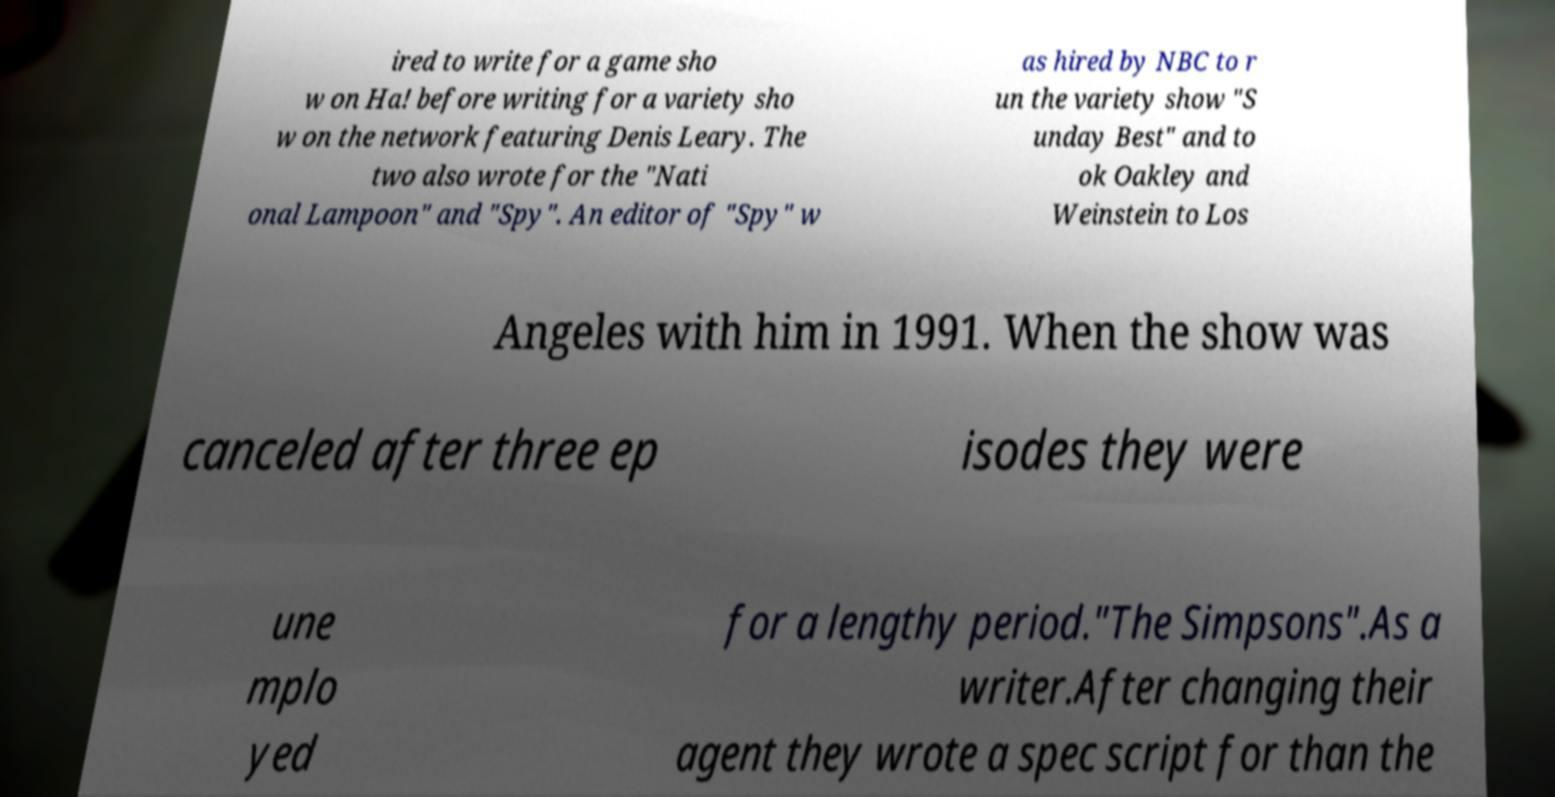Please identify and transcribe the text found in this image. ired to write for a game sho w on Ha! before writing for a variety sho w on the network featuring Denis Leary. The two also wrote for the "Nati onal Lampoon" and "Spy". An editor of "Spy" w as hired by NBC to r un the variety show "S unday Best" and to ok Oakley and Weinstein to Los Angeles with him in 1991. When the show was canceled after three ep isodes they were une mplo yed for a lengthy period."The Simpsons".As a writer.After changing their agent they wrote a spec script for than the 